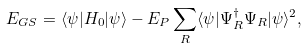<formula> <loc_0><loc_0><loc_500><loc_500>E _ { G S } = \langle \psi | H _ { 0 } | \psi \rangle - E _ { P } \sum _ { R } \langle \psi | \Psi ^ { \dagger } _ { R } \Psi _ { R } | \psi \rangle ^ { 2 } ,</formula> 